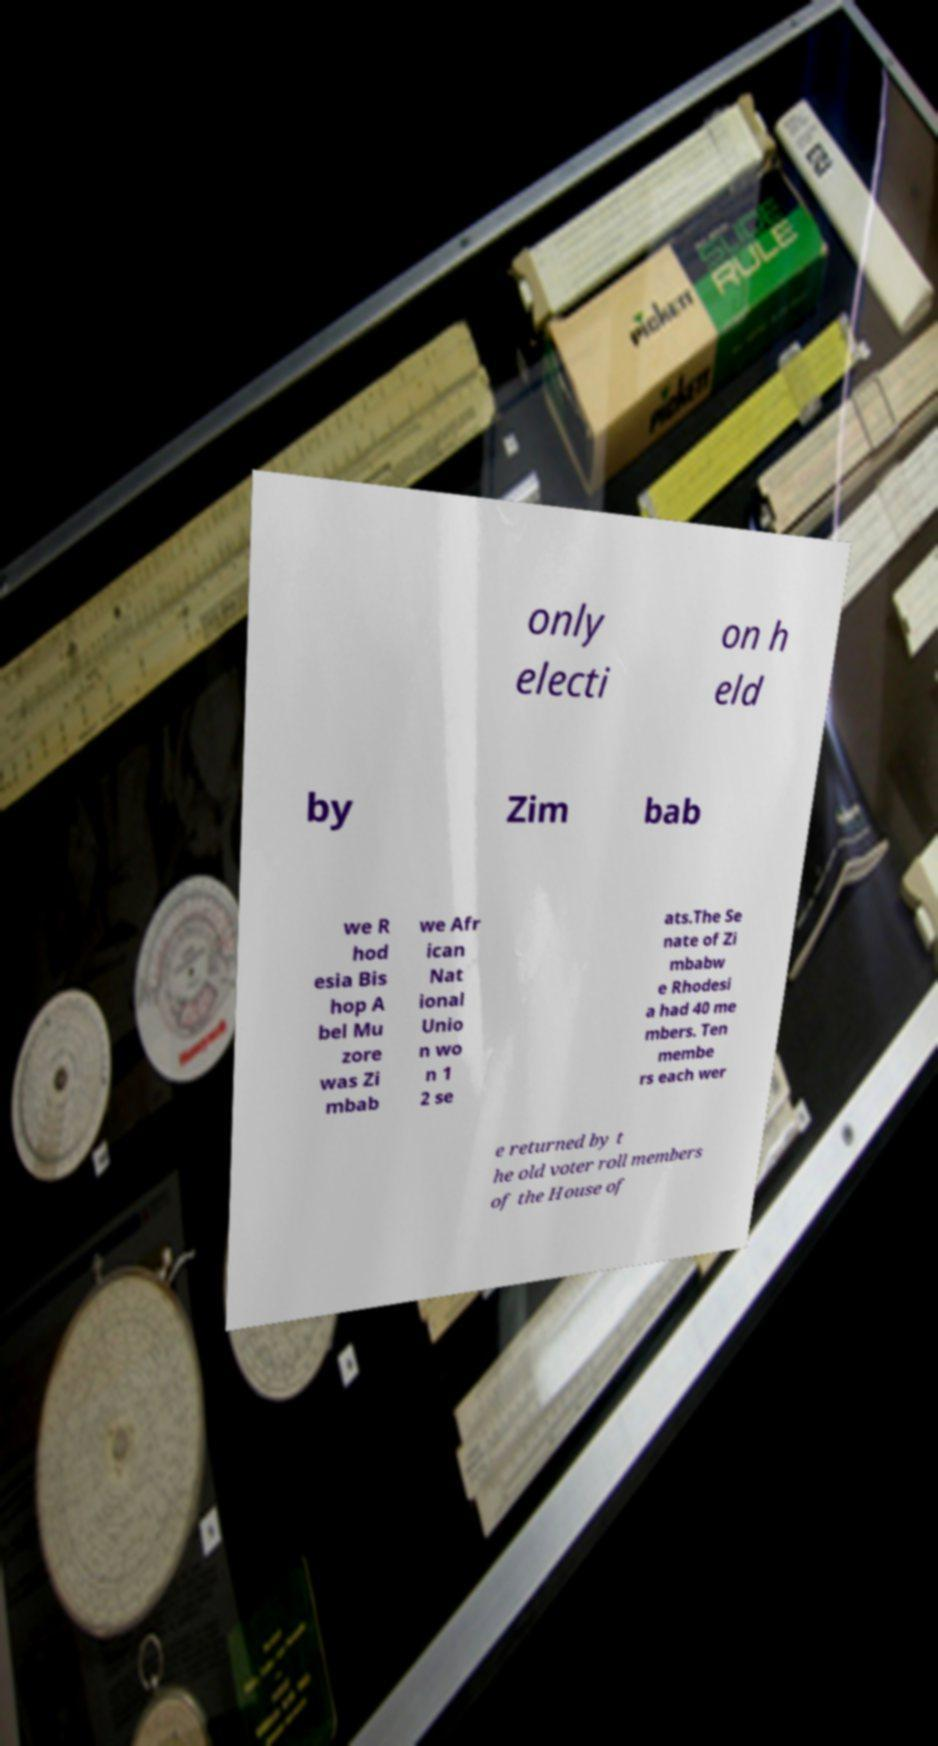Can you read and provide the text displayed in the image?This photo seems to have some interesting text. Can you extract and type it out for me? only electi on h eld by Zim bab we R hod esia Bis hop A bel Mu zore was Zi mbab we Afr ican Nat ional Unio n wo n 1 2 se ats.The Se nate of Zi mbabw e Rhodesi a had 40 me mbers. Ten membe rs each wer e returned by t he old voter roll members of the House of 